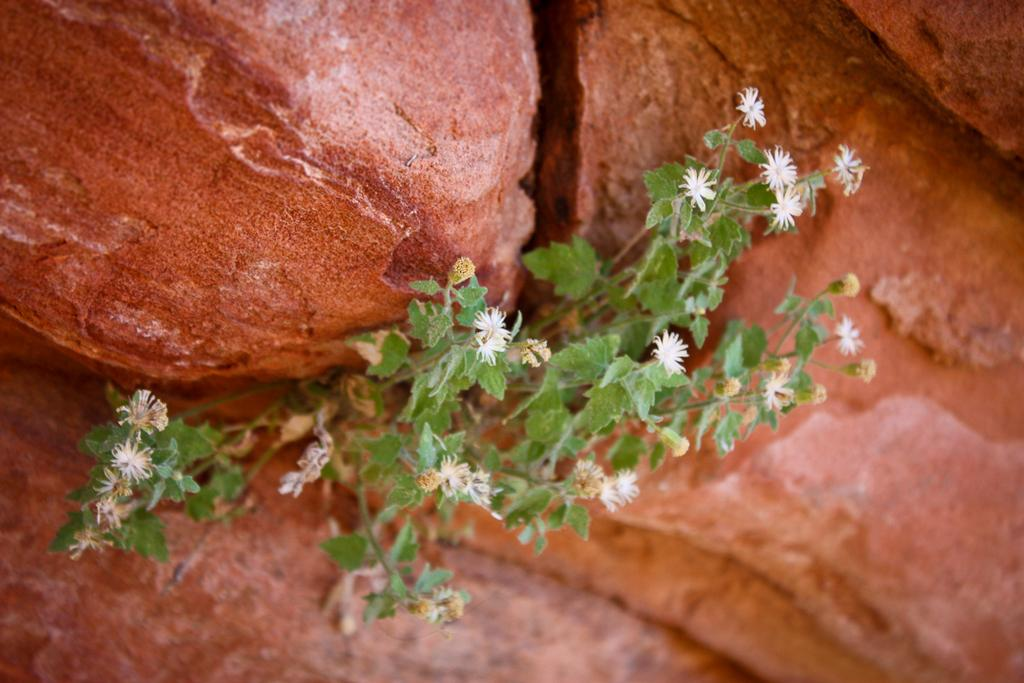What is located in the center of the image? There are flowers and plants in the center of the image. Can you describe the plants in the image? The plants in the image are flowers. What can be seen in the background of the image? There are rocks in the background of the image. What type of collar can be seen on the hands in the image? There are no hands or collars present in the image; it features flowers and plants in the center and rocks in the background. 